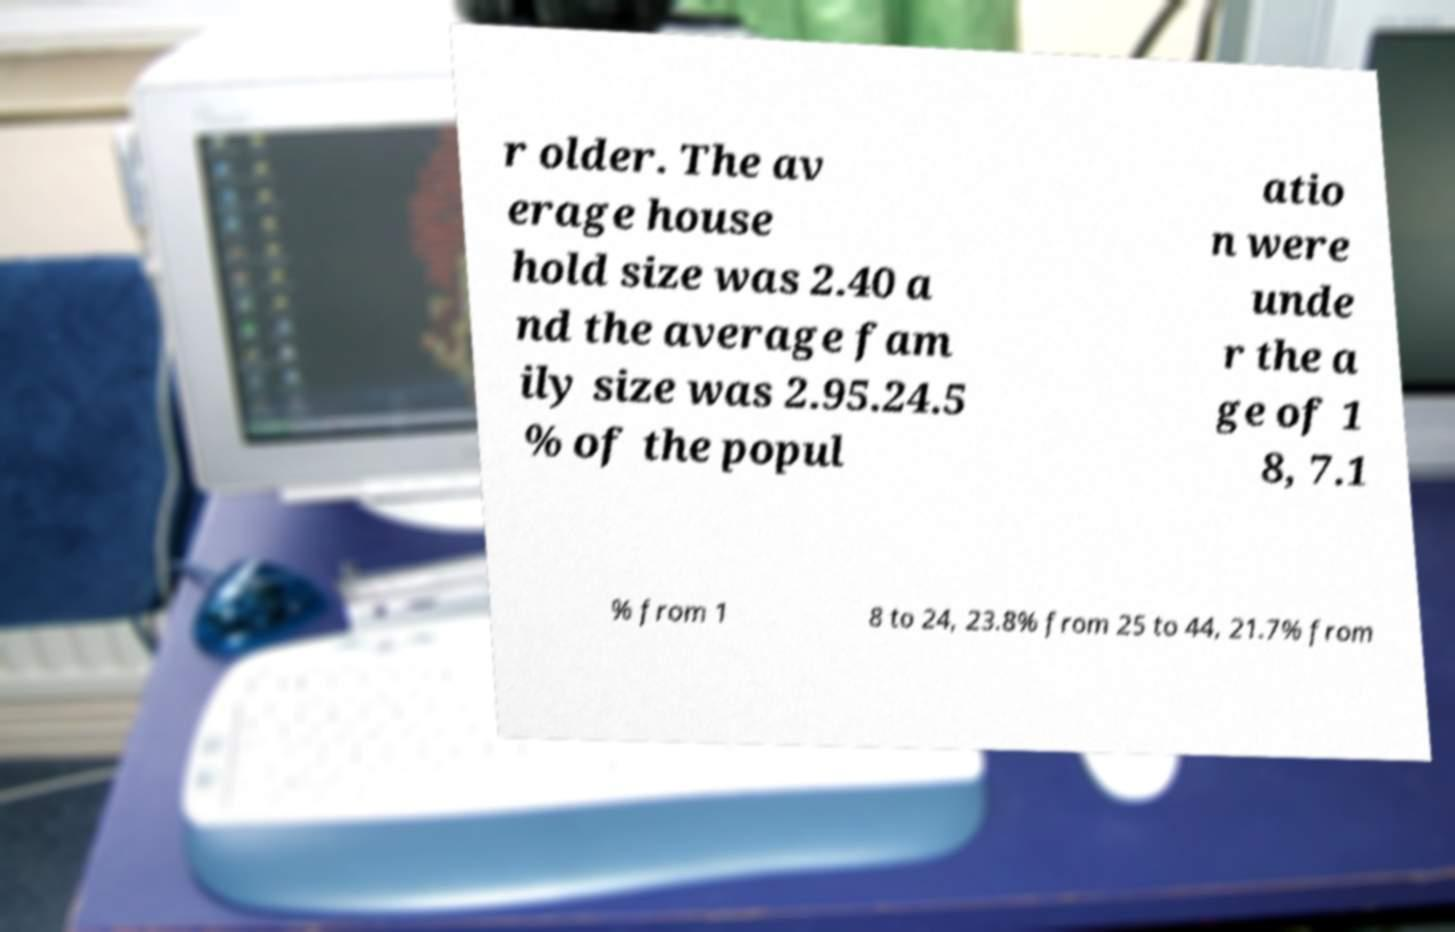I need the written content from this picture converted into text. Can you do that? r older. The av erage house hold size was 2.40 a nd the average fam ily size was 2.95.24.5 % of the popul atio n were unde r the a ge of 1 8, 7.1 % from 1 8 to 24, 23.8% from 25 to 44, 21.7% from 